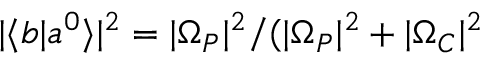Convert formula to latex. <formula><loc_0><loc_0><loc_500><loc_500>| \langle b | a ^ { 0 } \rangle | ^ { 2 } = | \Omega _ { P } | ^ { 2 } / ( | \Omega _ { P } | ^ { 2 } + | \Omega _ { C } | ^ { 2 }</formula> 